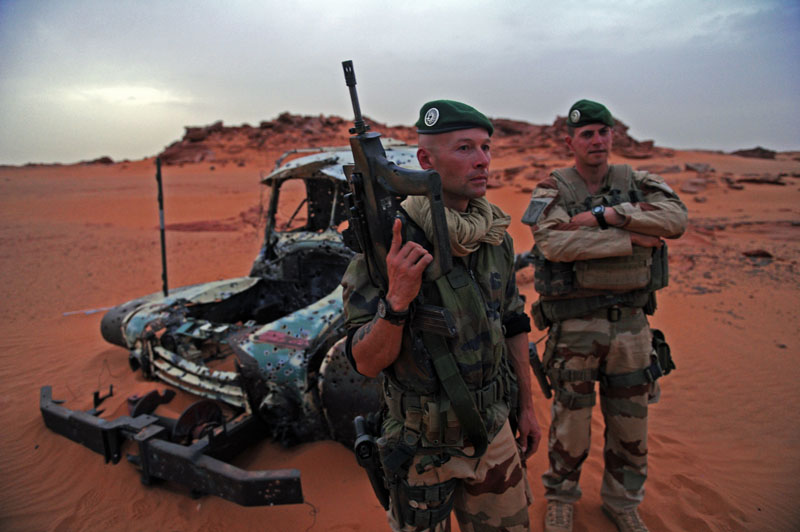Considering the environmental conditions, what challenges might the soldiers face in such a terrain? In this desert environment, soldiers are likely to encounter several significant challenges. The extreme heat and exposure to the elements can cause dehydration and heat-related illnesses such as heat exhaustion or heatstroke. The fine sand present can get into gear and weaponry, potentially causing malfunctions and reducing operational efficiency. Navigating the terrain is difficult due to the lack of prominent landmarks, increasing the risk of disorientation. Soft sand can hinder the movement of vehicles and personnel, making logistical operations and emergencies more challenging. The isolation of the area means limited access to immediate support or rescue, which is critical for both routine missions and emergencies. Additionally, the presence of helicopter wreckage suggests that even air travel in this region can be perilous, possibly due to severe weather conditions, strong winds, or uncharted obstacles on the ground. 